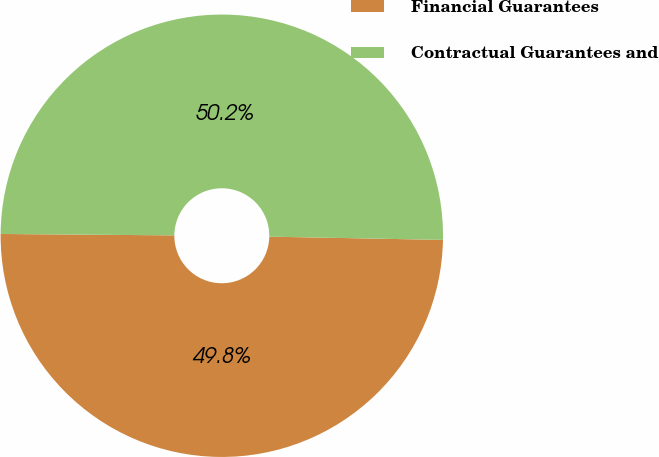Convert chart to OTSL. <chart><loc_0><loc_0><loc_500><loc_500><pie_chart><fcel>Financial Guarantees<fcel>Contractual Guarantees and<nl><fcel>49.83%<fcel>50.17%<nl></chart> 